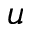<formula> <loc_0><loc_0><loc_500><loc_500>u</formula> 